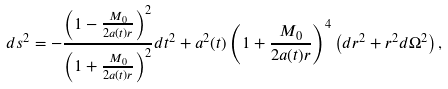Convert formula to latex. <formula><loc_0><loc_0><loc_500><loc_500>d s ^ { 2 } = - \frac { \left ( 1 - \frac { M _ { 0 } } { 2 a ( t ) r } \right ) ^ { 2 } } { \left ( 1 + \frac { M _ { 0 } } { 2 a ( t ) r } \right ) ^ { 2 } } d t ^ { 2 } + a ^ { 2 } ( t ) \left ( 1 + \frac { M _ { 0 } } { 2 a ( t ) r } \right ) ^ { 4 } \left ( d r ^ { 2 } + r ^ { 2 } d \Omega ^ { 2 } \right ) ,</formula> 